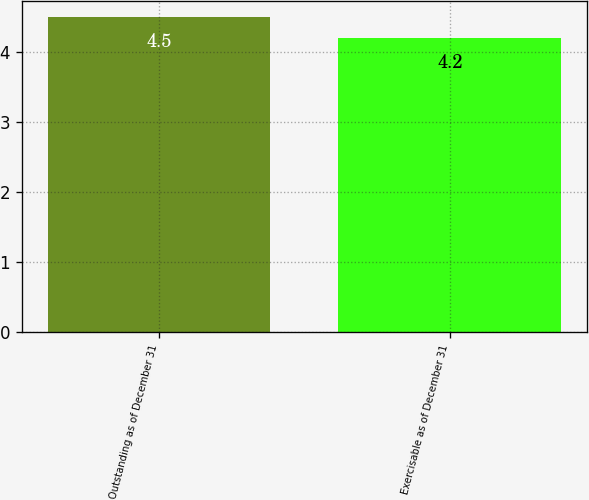Convert chart. <chart><loc_0><loc_0><loc_500><loc_500><bar_chart><fcel>Outstanding as of December 31<fcel>Exercisable as of December 31<nl><fcel>4.5<fcel>4.2<nl></chart> 